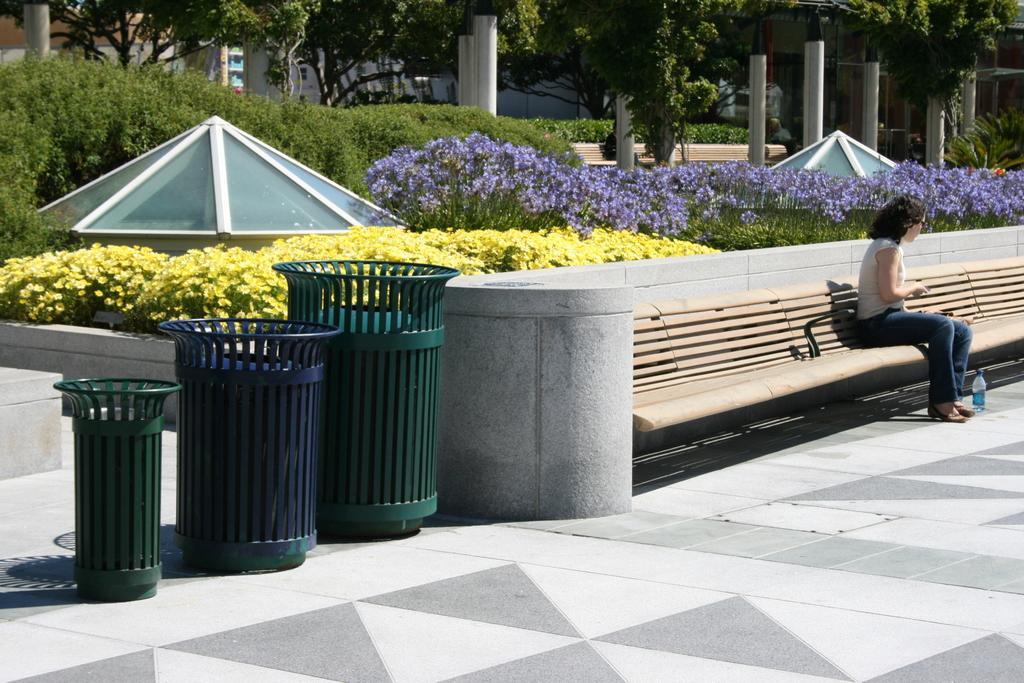Can you describe this image briefly? there is a road. at the left there are 3 baskets which are blue and green in color. at the right there is a wooden bench on which a woman is sitting. there is a plastic water bottle on the floor. behind her there are yellow and lavender flower plants. behind that there are plants and trees. at the back there are buildings. 